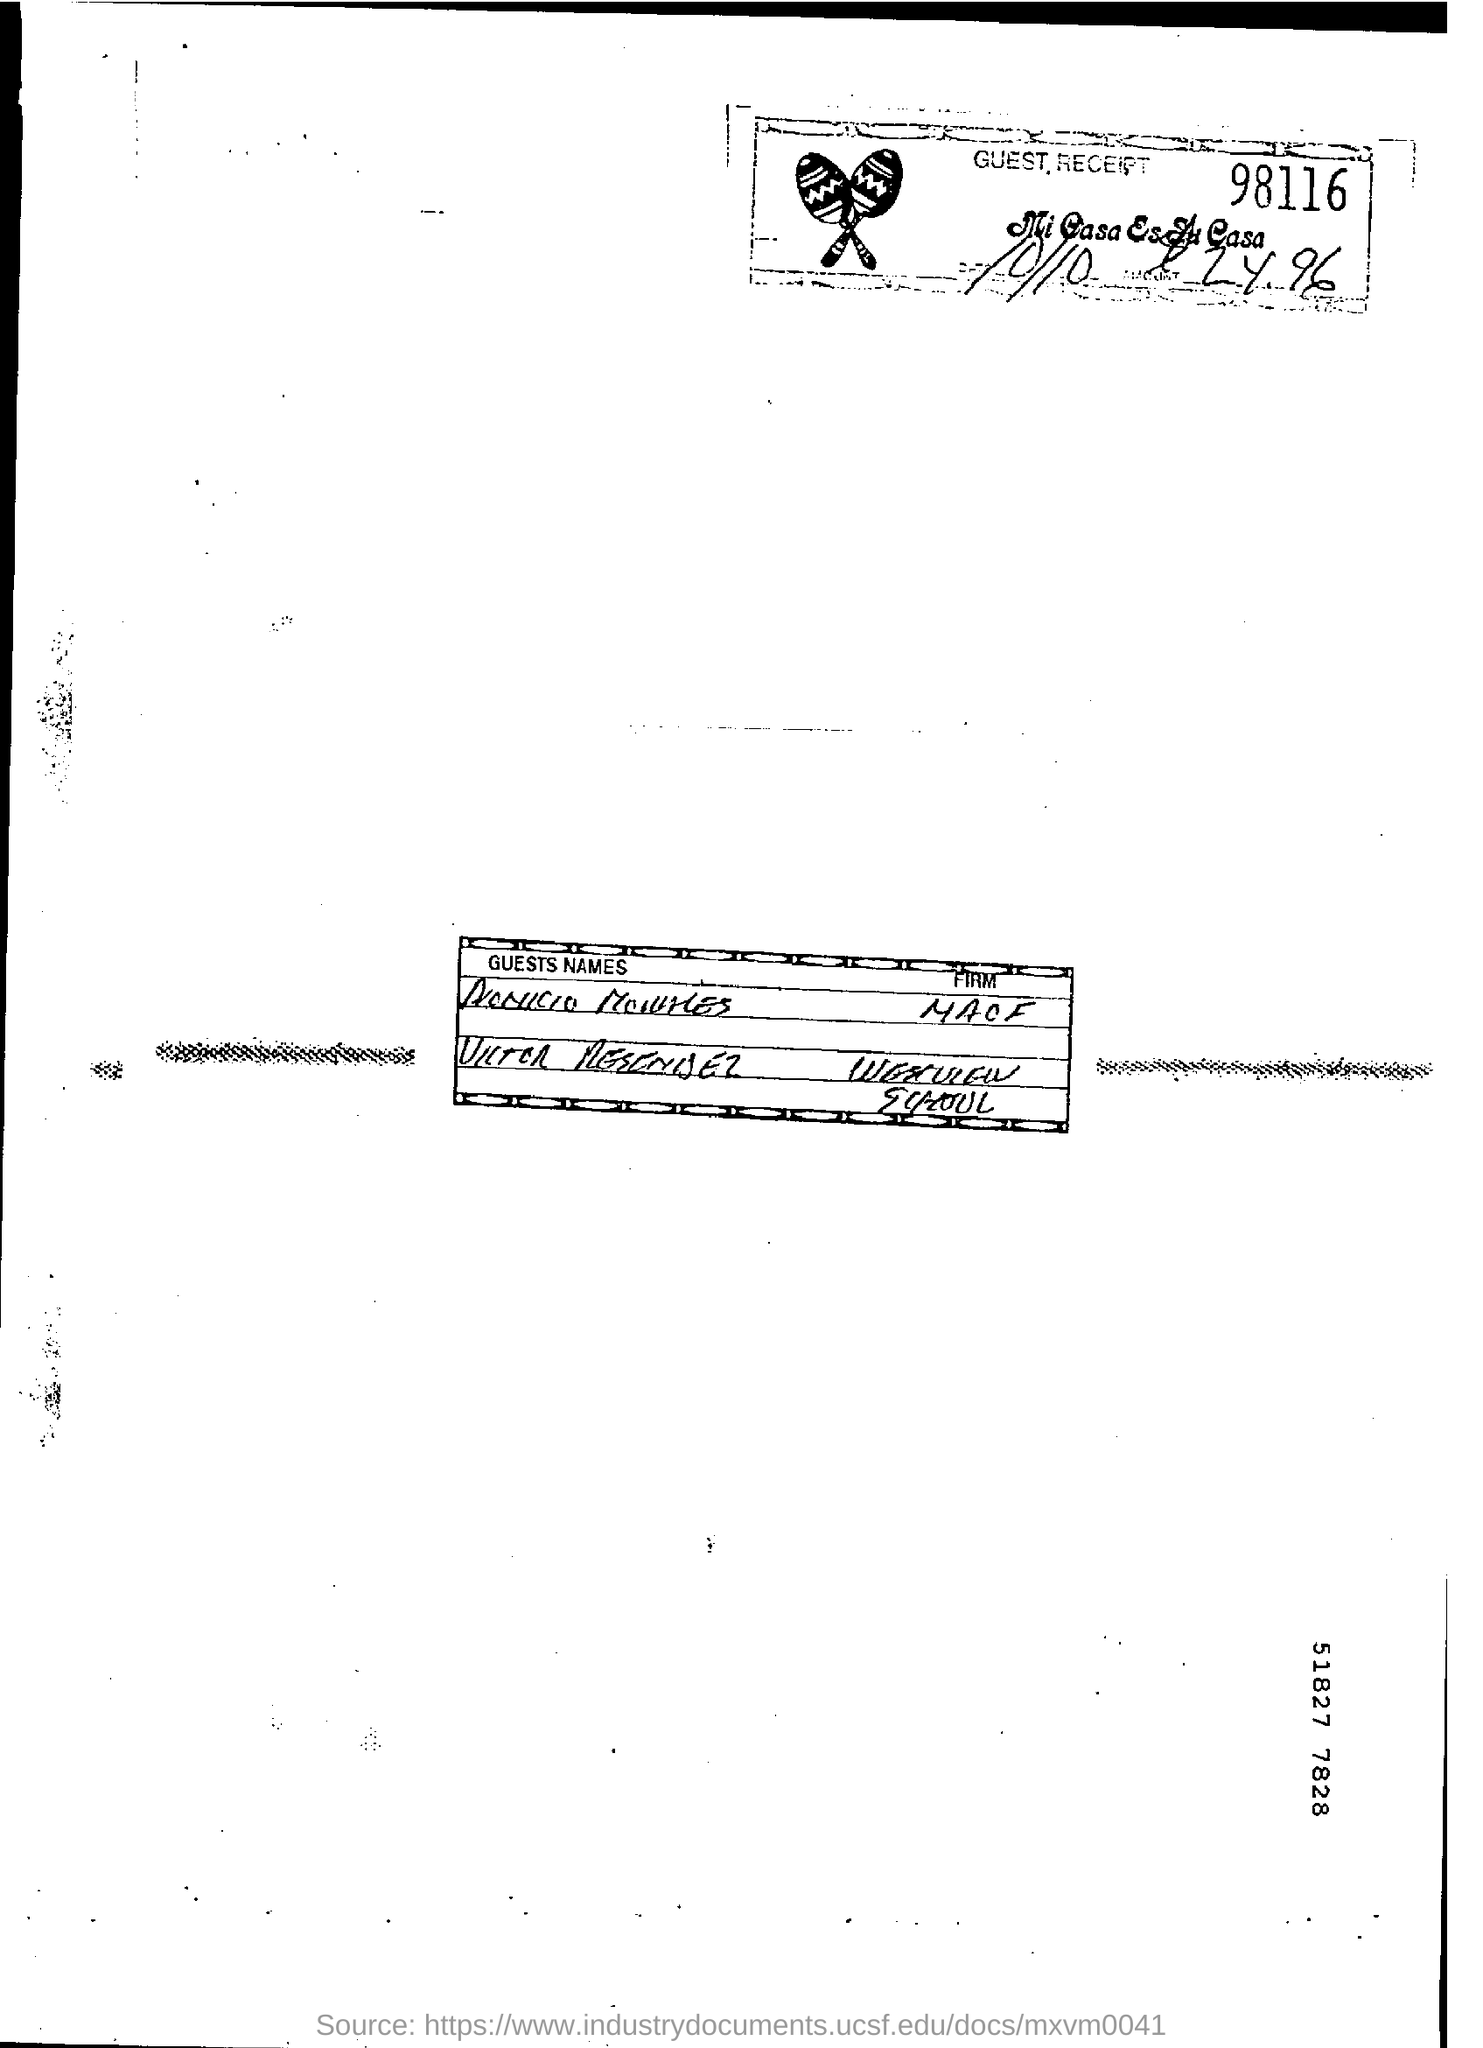What is the guest recept number in the document?
Make the answer very short. 98116. 